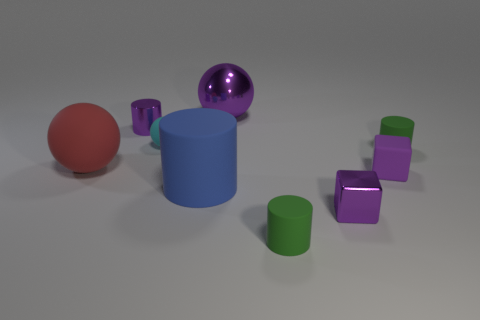Add 1 tiny blue matte blocks. How many objects exist? 10 Subtract all spheres. How many objects are left? 6 Add 5 small purple things. How many small purple things exist? 8 Subtract 1 purple balls. How many objects are left? 8 Subtract all big green spheres. Subtract all small matte things. How many objects are left? 5 Add 1 big blue things. How many big blue things are left? 2 